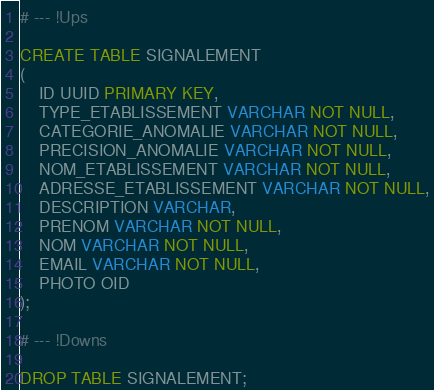<code> <loc_0><loc_0><loc_500><loc_500><_SQL_># --- !Ups

CREATE TABLE SIGNALEMENT
(
    ID UUID PRIMARY KEY,
    TYPE_ETABLISSEMENT VARCHAR NOT NULL,
    CATEGORIE_ANOMALIE VARCHAR NOT NULL,
    PRECISION_ANOMALIE VARCHAR NOT NULL,
    NOM_ETABLISSEMENT VARCHAR NOT NULL,
    ADRESSE_ETABLISSEMENT VARCHAR NOT NULL,
    DESCRIPTION VARCHAR,
    PRENOM VARCHAR NOT NULL,
    NOM VARCHAR NOT NULL,
    EMAIL VARCHAR NOT NULL,
    PHOTO OID
);

# --- !Downs

DROP TABLE SIGNALEMENT;</code> 